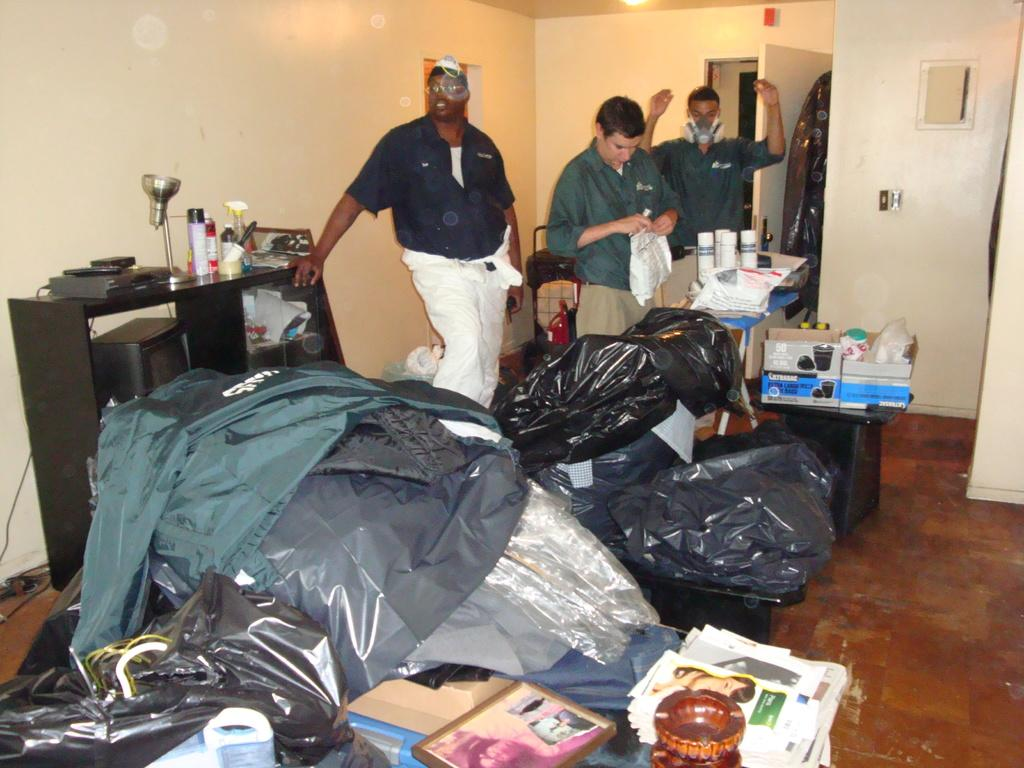How many people are in the image? There are three men in the image. Where are the men located? The men are standing in a room. What furniture is present in the room? There is a table in the room. Can you describe the contents of the room? There is a lot of stuff visible in the room. What type of industry is depicted in the image? There is no industry depicted in the image; it features three men standing in a room. How do the men behave in the image? The behavior of the men cannot be determined from the image alone, as it only shows their physical appearance and location. 